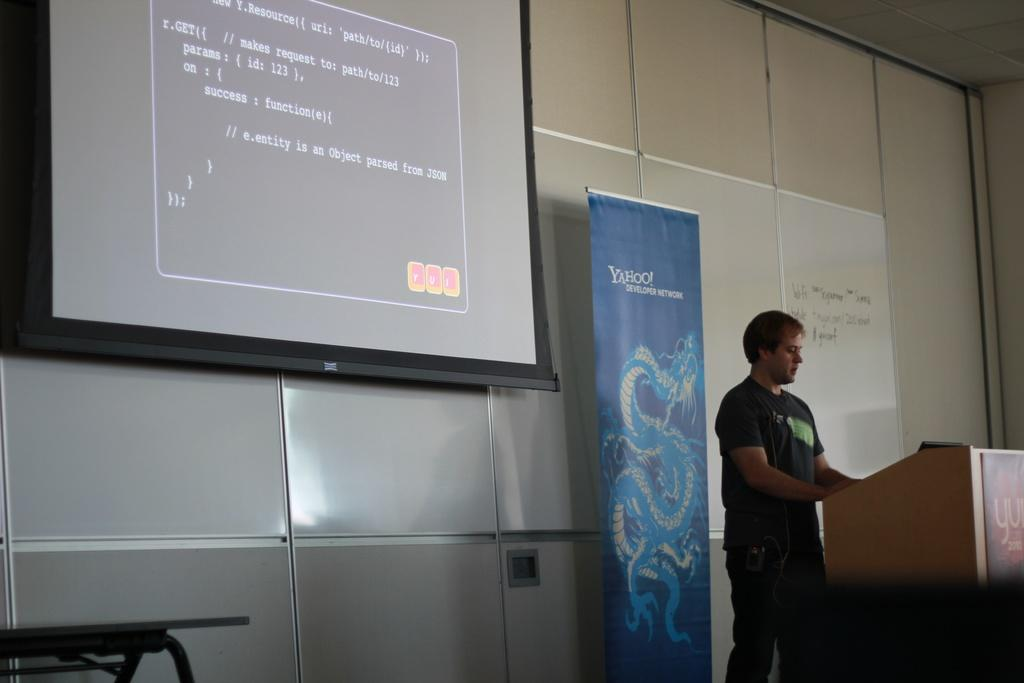<image>
Render a clear and concise summary of the photo. A man standing behind a podium and in front of a banner reading Yahoo Developer Network. 